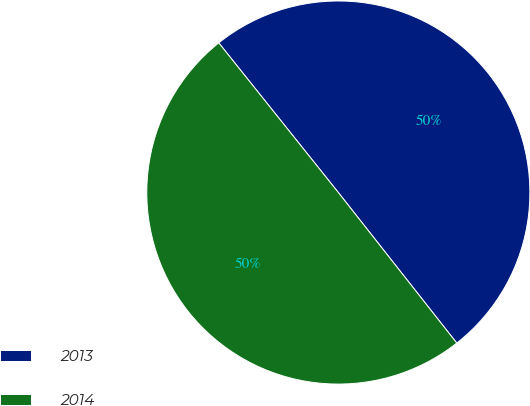Convert chart to OTSL. <chart><loc_0><loc_0><loc_500><loc_500><pie_chart><fcel>2013<fcel>2014<nl><fcel>50.12%<fcel>49.88%<nl></chart> 